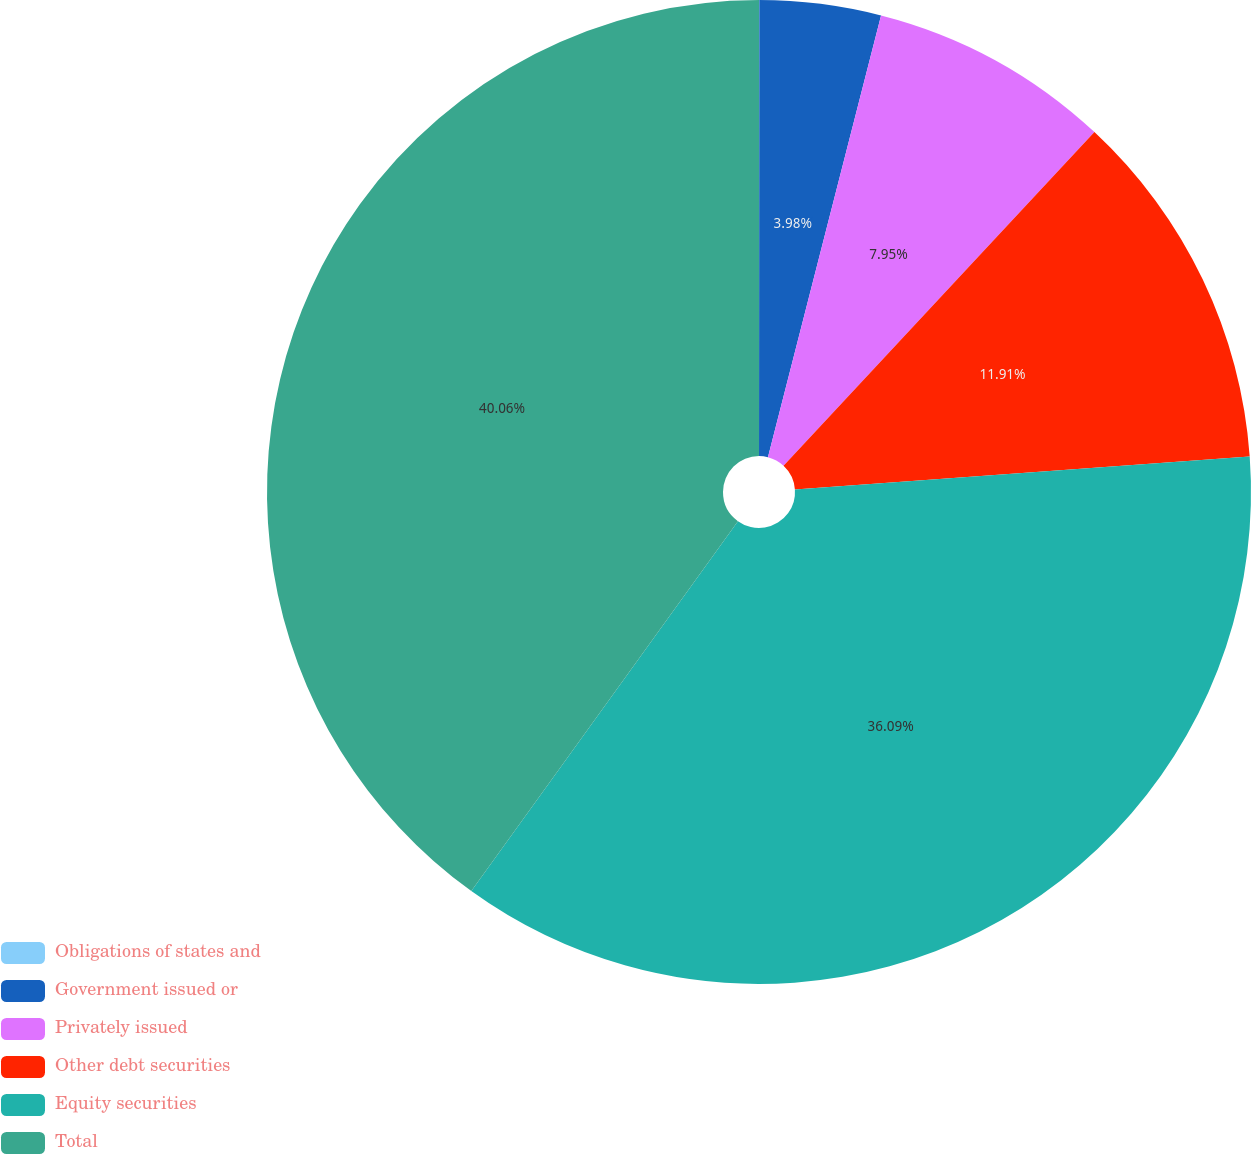<chart> <loc_0><loc_0><loc_500><loc_500><pie_chart><fcel>Obligations of states and<fcel>Government issued or<fcel>Privately issued<fcel>Other debt securities<fcel>Equity securities<fcel>Total<nl><fcel>0.01%<fcel>3.98%<fcel>7.95%<fcel>11.91%<fcel>36.09%<fcel>40.06%<nl></chart> 